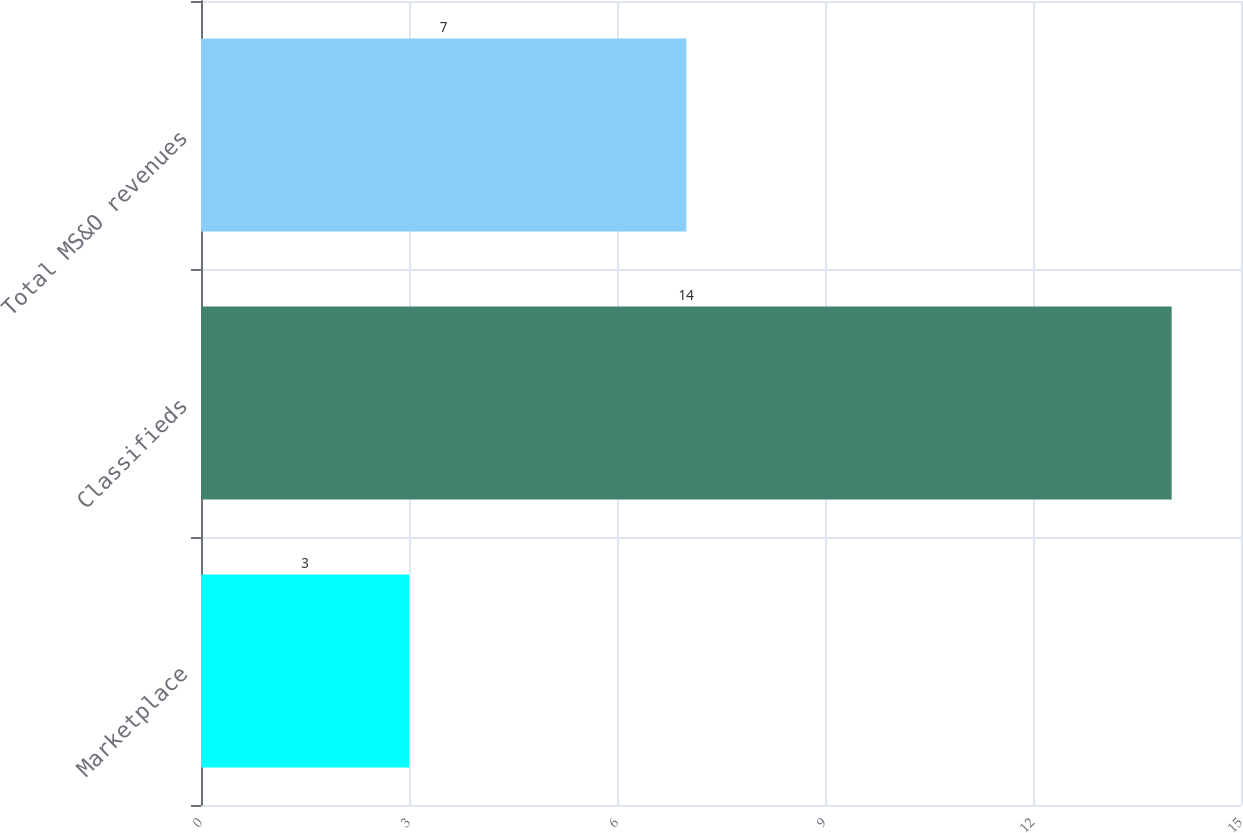<chart> <loc_0><loc_0><loc_500><loc_500><bar_chart><fcel>Marketplace<fcel>Classifieds<fcel>Total MS&O revenues<nl><fcel>3<fcel>14<fcel>7<nl></chart> 